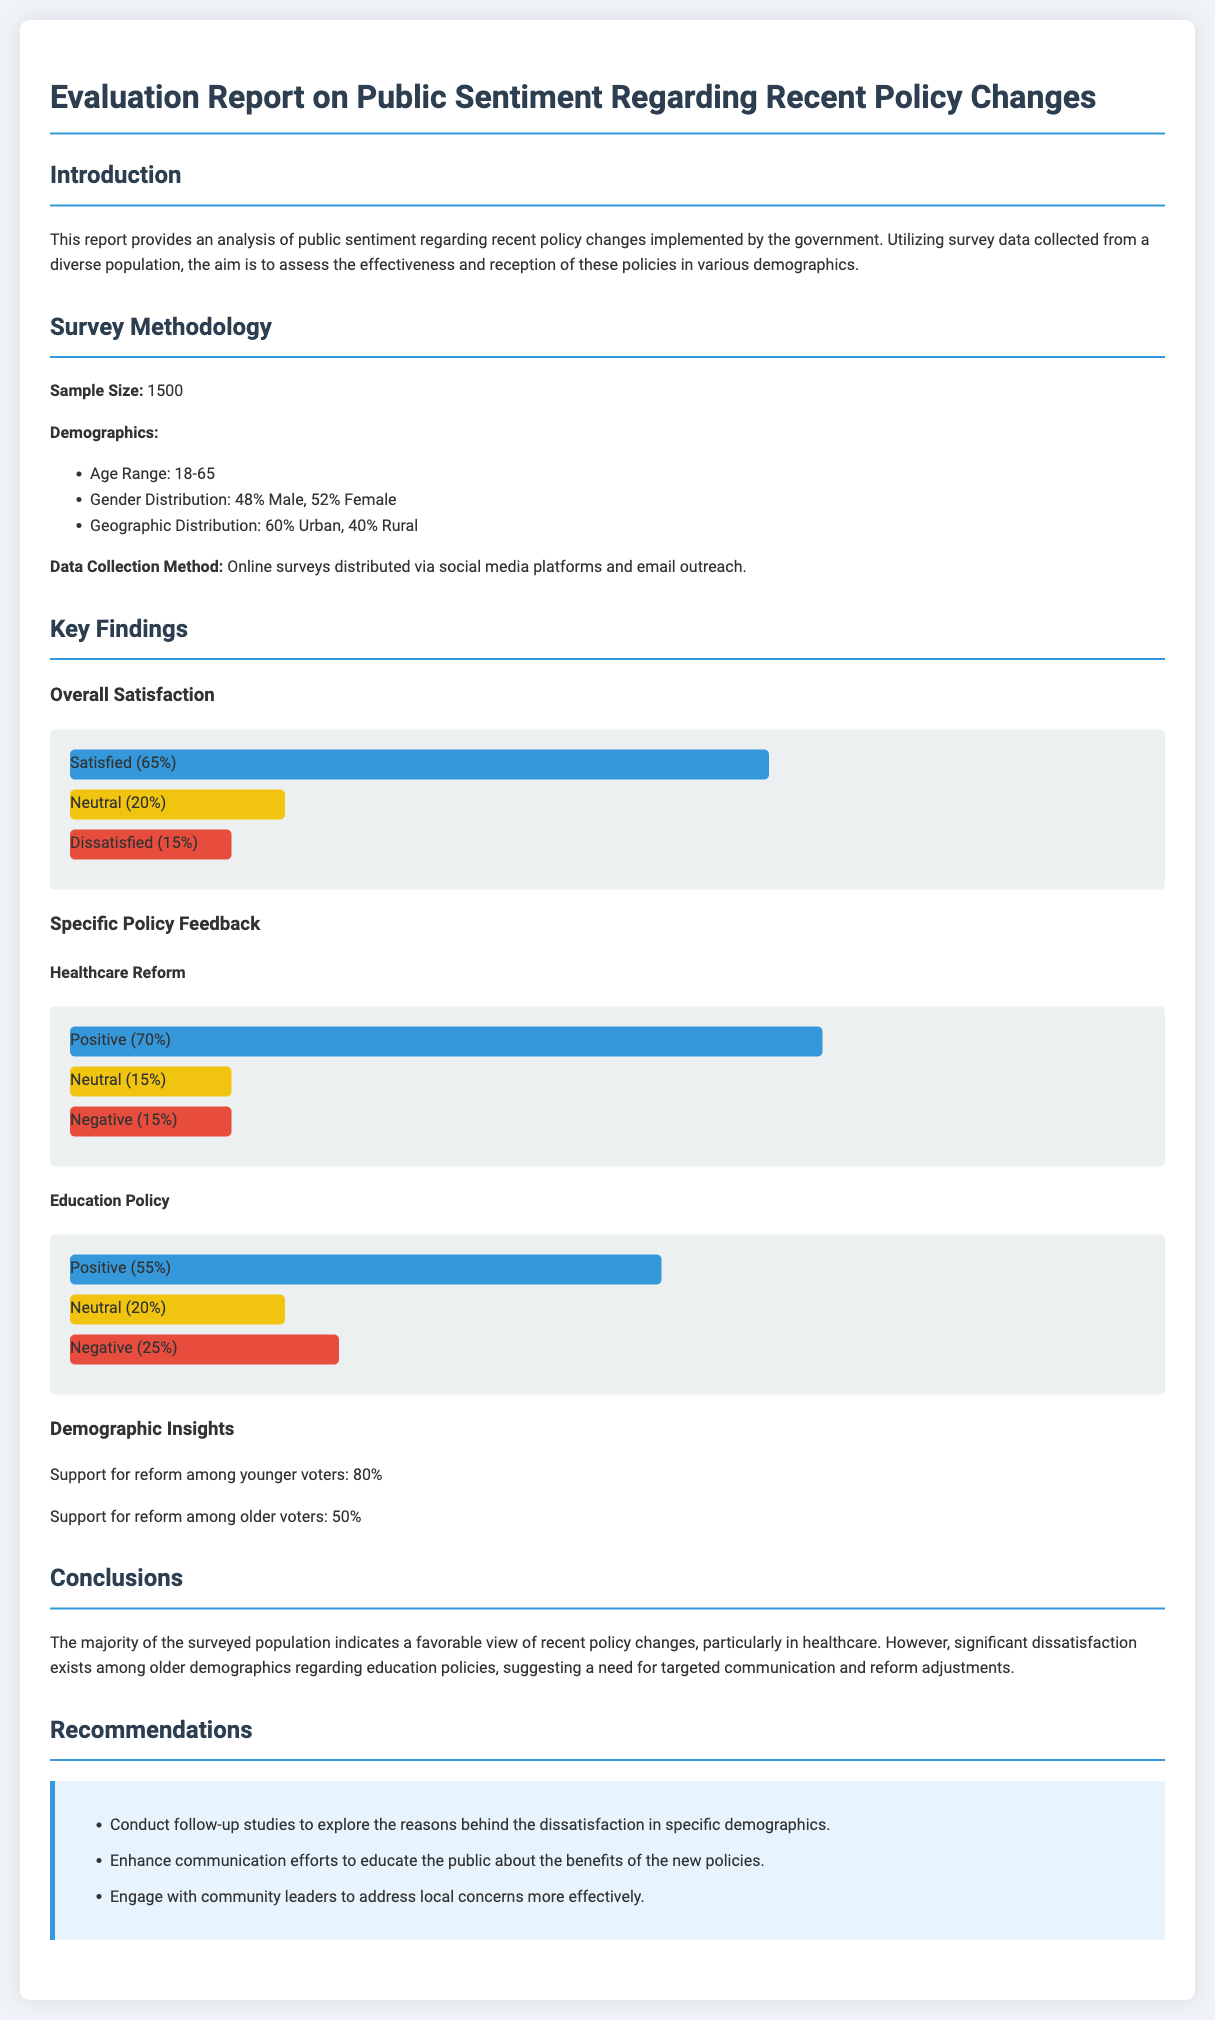What is the sample size of the survey? The sample size is explicitly stated in the methodology section of the document, which is 1500.
Answer: 1500 What percentage of respondents were satisfied with the policies? The overall satisfaction rate is provided in the key findings section, indicating that 65% of respondents were satisfied.
Answer: 65% What is the percentage of positive feedback for healthcare reform? The specific feedback for healthcare reform shows that 70% of respondents had a positive impression.
Answer: 70% What demographic showed 80% support for the reform? The demographic insights indicate that younger voters, specifically, showed 80% support for the reform.
Answer: Younger voters What is one recommendation made in the report? The recommendations section lists several suggestions, one of which is to conduct follow-up studies to explore reasons behind dissatisfaction.
Answer: Conduct follow-up studies What percentage of respondents felt negative about the education policy? The chart for education policy shows that 25% of respondents expressed a negative view.
Answer: 25% What is the gender distribution of the survey population? The demographics provided in the survey methodology state the gender distribution as 48% male and 52% female.
Answer: 48% Male, 52% Female How do older voters' support for reform compare to younger voters? The demographic insights reveal that 50% of older voters support the reform, which is significantly lower than the 80% support from younger voters.
Answer: 50% vs 80% What is the main conclusion drawn from the survey analysis? The conclusions section summarizes that the majority view recent policy changes favorably, particularly in healthcare, but highlights dissatisfaction among older demographics.
Answer: Favorable view on healthcare reform 